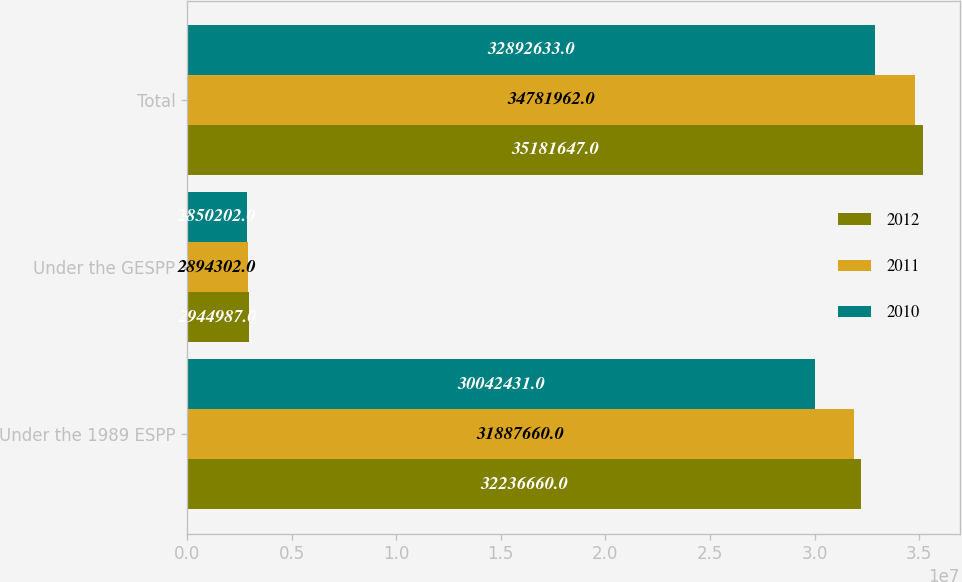<chart> <loc_0><loc_0><loc_500><loc_500><stacked_bar_chart><ecel><fcel>Under the 1989 ESPP<fcel>Under the GESPP<fcel>Total<nl><fcel>2012<fcel>3.22367e+07<fcel>2.94499e+06<fcel>3.51816e+07<nl><fcel>2011<fcel>3.18877e+07<fcel>2.8943e+06<fcel>3.4782e+07<nl><fcel>2010<fcel>3.00424e+07<fcel>2.8502e+06<fcel>3.28926e+07<nl></chart> 